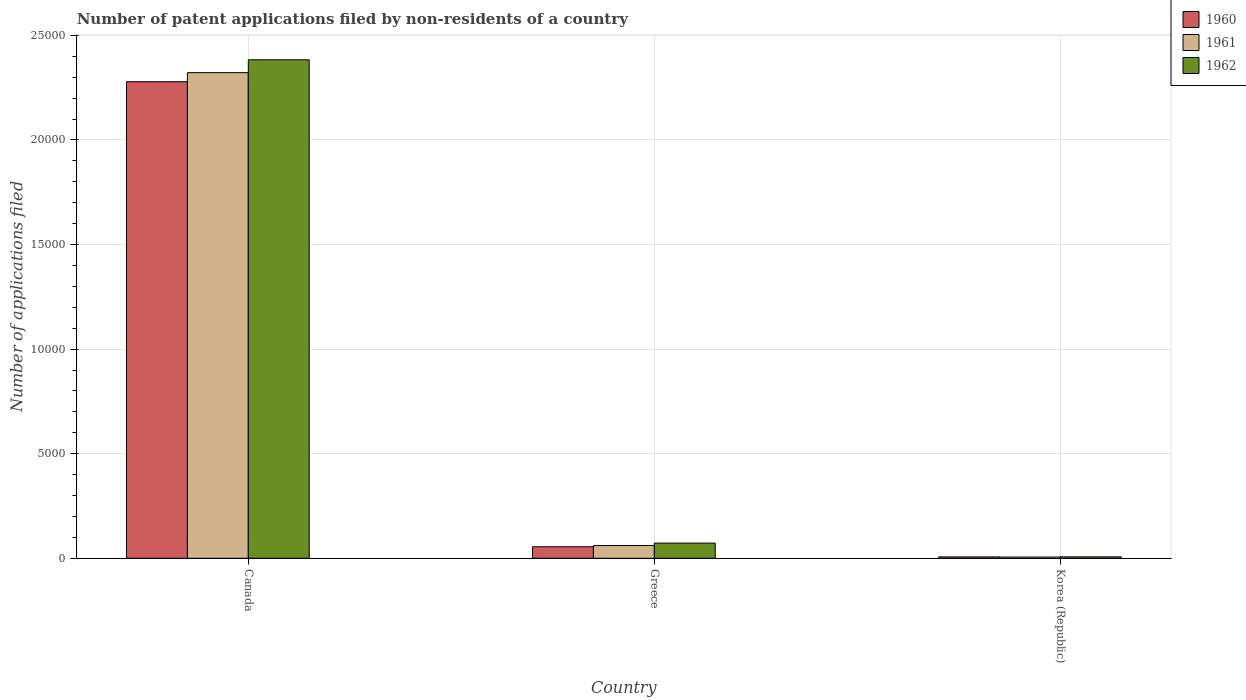How many different coloured bars are there?
Offer a very short reply. 3. Are the number of bars per tick equal to the number of legend labels?
Provide a short and direct response. Yes. How many bars are there on the 1st tick from the left?
Your response must be concise. 3. How many bars are there on the 2nd tick from the right?
Your answer should be compact. 3. What is the number of applications filed in 1960 in Canada?
Offer a terse response. 2.28e+04. Across all countries, what is the maximum number of applications filed in 1960?
Your response must be concise. 2.28e+04. Across all countries, what is the minimum number of applications filed in 1961?
Offer a very short reply. 58. What is the total number of applications filed in 1962 in the graph?
Ensure brevity in your answer.  2.46e+04. What is the difference between the number of applications filed in 1961 in Canada and that in Greece?
Give a very brief answer. 2.26e+04. What is the difference between the number of applications filed in 1962 in Canada and the number of applications filed in 1961 in Greece?
Offer a terse response. 2.32e+04. What is the average number of applications filed in 1962 per country?
Ensure brevity in your answer.  8209.33. What is the difference between the number of applications filed of/in 1960 and number of applications filed of/in 1961 in Canada?
Provide a short and direct response. -433. In how many countries, is the number of applications filed in 1962 greater than 6000?
Provide a succinct answer. 1. What is the ratio of the number of applications filed in 1961 in Canada to that in Greece?
Keep it short and to the point. 38.13. Is the number of applications filed in 1962 in Canada less than that in Greece?
Your answer should be compact. No. What is the difference between the highest and the second highest number of applications filed in 1962?
Make the answer very short. 2.38e+04. What is the difference between the highest and the lowest number of applications filed in 1961?
Offer a very short reply. 2.32e+04. What does the 1st bar from the left in Greece represents?
Give a very brief answer. 1960. What does the 2nd bar from the right in Canada represents?
Your answer should be very brief. 1961. How many countries are there in the graph?
Ensure brevity in your answer.  3. How many legend labels are there?
Make the answer very short. 3. How are the legend labels stacked?
Your answer should be very brief. Vertical. What is the title of the graph?
Provide a short and direct response. Number of patent applications filed by non-residents of a country. What is the label or title of the X-axis?
Your response must be concise. Country. What is the label or title of the Y-axis?
Offer a very short reply. Number of applications filed. What is the Number of applications filed in 1960 in Canada?
Ensure brevity in your answer.  2.28e+04. What is the Number of applications filed in 1961 in Canada?
Your answer should be compact. 2.32e+04. What is the Number of applications filed in 1962 in Canada?
Offer a terse response. 2.38e+04. What is the Number of applications filed of 1960 in Greece?
Your answer should be compact. 551. What is the Number of applications filed of 1961 in Greece?
Provide a short and direct response. 609. What is the Number of applications filed of 1962 in Greece?
Provide a succinct answer. 726. What is the Number of applications filed of 1960 in Korea (Republic)?
Offer a terse response. 66. What is the Number of applications filed of 1962 in Korea (Republic)?
Your answer should be compact. 68. Across all countries, what is the maximum Number of applications filed of 1960?
Your response must be concise. 2.28e+04. Across all countries, what is the maximum Number of applications filed of 1961?
Give a very brief answer. 2.32e+04. Across all countries, what is the maximum Number of applications filed in 1962?
Keep it short and to the point. 2.38e+04. Across all countries, what is the minimum Number of applications filed in 1960?
Make the answer very short. 66. Across all countries, what is the minimum Number of applications filed in 1962?
Make the answer very short. 68. What is the total Number of applications filed of 1960 in the graph?
Provide a short and direct response. 2.34e+04. What is the total Number of applications filed in 1961 in the graph?
Make the answer very short. 2.39e+04. What is the total Number of applications filed in 1962 in the graph?
Your answer should be compact. 2.46e+04. What is the difference between the Number of applications filed in 1960 in Canada and that in Greece?
Ensure brevity in your answer.  2.22e+04. What is the difference between the Number of applications filed in 1961 in Canada and that in Greece?
Ensure brevity in your answer.  2.26e+04. What is the difference between the Number of applications filed of 1962 in Canada and that in Greece?
Ensure brevity in your answer.  2.31e+04. What is the difference between the Number of applications filed in 1960 in Canada and that in Korea (Republic)?
Make the answer very short. 2.27e+04. What is the difference between the Number of applications filed in 1961 in Canada and that in Korea (Republic)?
Your answer should be compact. 2.32e+04. What is the difference between the Number of applications filed in 1962 in Canada and that in Korea (Republic)?
Provide a succinct answer. 2.38e+04. What is the difference between the Number of applications filed of 1960 in Greece and that in Korea (Republic)?
Your response must be concise. 485. What is the difference between the Number of applications filed of 1961 in Greece and that in Korea (Republic)?
Offer a very short reply. 551. What is the difference between the Number of applications filed in 1962 in Greece and that in Korea (Republic)?
Your answer should be compact. 658. What is the difference between the Number of applications filed of 1960 in Canada and the Number of applications filed of 1961 in Greece?
Provide a short and direct response. 2.22e+04. What is the difference between the Number of applications filed in 1960 in Canada and the Number of applications filed in 1962 in Greece?
Your answer should be very brief. 2.21e+04. What is the difference between the Number of applications filed of 1961 in Canada and the Number of applications filed of 1962 in Greece?
Give a very brief answer. 2.25e+04. What is the difference between the Number of applications filed in 1960 in Canada and the Number of applications filed in 1961 in Korea (Republic)?
Offer a very short reply. 2.27e+04. What is the difference between the Number of applications filed of 1960 in Canada and the Number of applications filed of 1962 in Korea (Republic)?
Offer a very short reply. 2.27e+04. What is the difference between the Number of applications filed in 1961 in Canada and the Number of applications filed in 1962 in Korea (Republic)?
Offer a very short reply. 2.32e+04. What is the difference between the Number of applications filed of 1960 in Greece and the Number of applications filed of 1961 in Korea (Republic)?
Your answer should be compact. 493. What is the difference between the Number of applications filed of 1960 in Greece and the Number of applications filed of 1962 in Korea (Republic)?
Give a very brief answer. 483. What is the difference between the Number of applications filed of 1961 in Greece and the Number of applications filed of 1962 in Korea (Republic)?
Ensure brevity in your answer.  541. What is the average Number of applications filed of 1960 per country?
Offer a terse response. 7801. What is the average Number of applications filed in 1961 per country?
Keep it short and to the point. 7962. What is the average Number of applications filed in 1962 per country?
Provide a succinct answer. 8209.33. What is the difference between the Number of applications filed in 1960 and Number of applications filed in 1961 in Canada?
Offer a very short reply. -433. What is the difference between the Number of applications filed of 1960 and Number of applications filed of 1962 in Canada?
Your response must be concise. -1048. What is the difference between the Number of applications filed in 1961 and Number of applications filed in 1962 in Canada?
Keep it short and to the point. -615. What is the difference between the Number of applications filed of 1960 and Number of applications filed of 1961 in Greece?
Keep it short and to the point. -58. What is the difference between the Number of applications filed in 1960 and Number of applications filed in 1962 in Greece?
Provide a succinct answer. -175. What is the difference between the Number of applications filed in 1961 and Number of applications filed in 1962 in Greece?
Keep it short and to the point. -117. What is the difference between the Number of applications filed in 1960 and Number of applications filed in 1961 in Korea (Republic)?
Provide a succinct answer. 8. What is the difference between the Number of applications filed of 1960 and Number of applications filed of 1962 in Korea (Republic)?
Your answer should be very brief. -2. What is the difference between the Number of applications filed of 1961 and Number of applications filed of 1962 in Korea (Republic)?
Your answer should be compact. -10. What is the ratio of the Number of applications filed in 1960 in Canada to that in Greece?
Give a very brief answer. 41.35. What is the ratio of the Number of applications filed in 1961 in Canada to that in Greece?
Give a very brief answer. 38.13. What is the ratio of the Number of applications filed in 1962 in Canada to that in Greece?
Offer a very short reply. 32.83. What is the ratio of the Number of applications filed of 1960 in Canada to that in Korea (Republic)?
Make the answer very short. 345.24. What is the ratio of the Number of applications filed of 1961 in Canada to that in Korea (Republic)?
Your response must be concise. 400.33. What is the ratio of the Number of applications filed in 1962 in Canada to that in Korea (Republic)?
Your response must be concise. 350.5. What is the ratio of the Number of applications filed in 1960 in Greece to that in Korea (Republic)?
Provide a succinct answer. 8.35. What is the ratio of the Number of applications filed of 1961 in Greece to that in Korea (Republic)?
Your answer should be compact. 10.5. What is the ratio of the Number of applications filed in 1962 in Greece to that in Korea (Republic)?
Offer a terse response. 10.68. What is the difference between the highest and the second highest Number of applications filed of 1960?
Keep it short and to the point. 2.22e+04. What is the difference between the highest and the second highest Number of applications filed of 1961?
Your answer should be very brief. 2.26e+04. What is the difference between the highest and the second highest Number of applications filed in 1962?
Your answer should be compact. 2.31e+04. What is the difference between the highest and the lowest Number of applications filed of 1960?
Offer a terse response. 2.27e+04. What is the difference between the highest and the lowest Number of applications filed in 1961?
Make the answer very short. 2.32e+04. What is the difference between the highest and the lowest Number of applications filed of 1962?
Offer a terse response. 2.38e+04. 